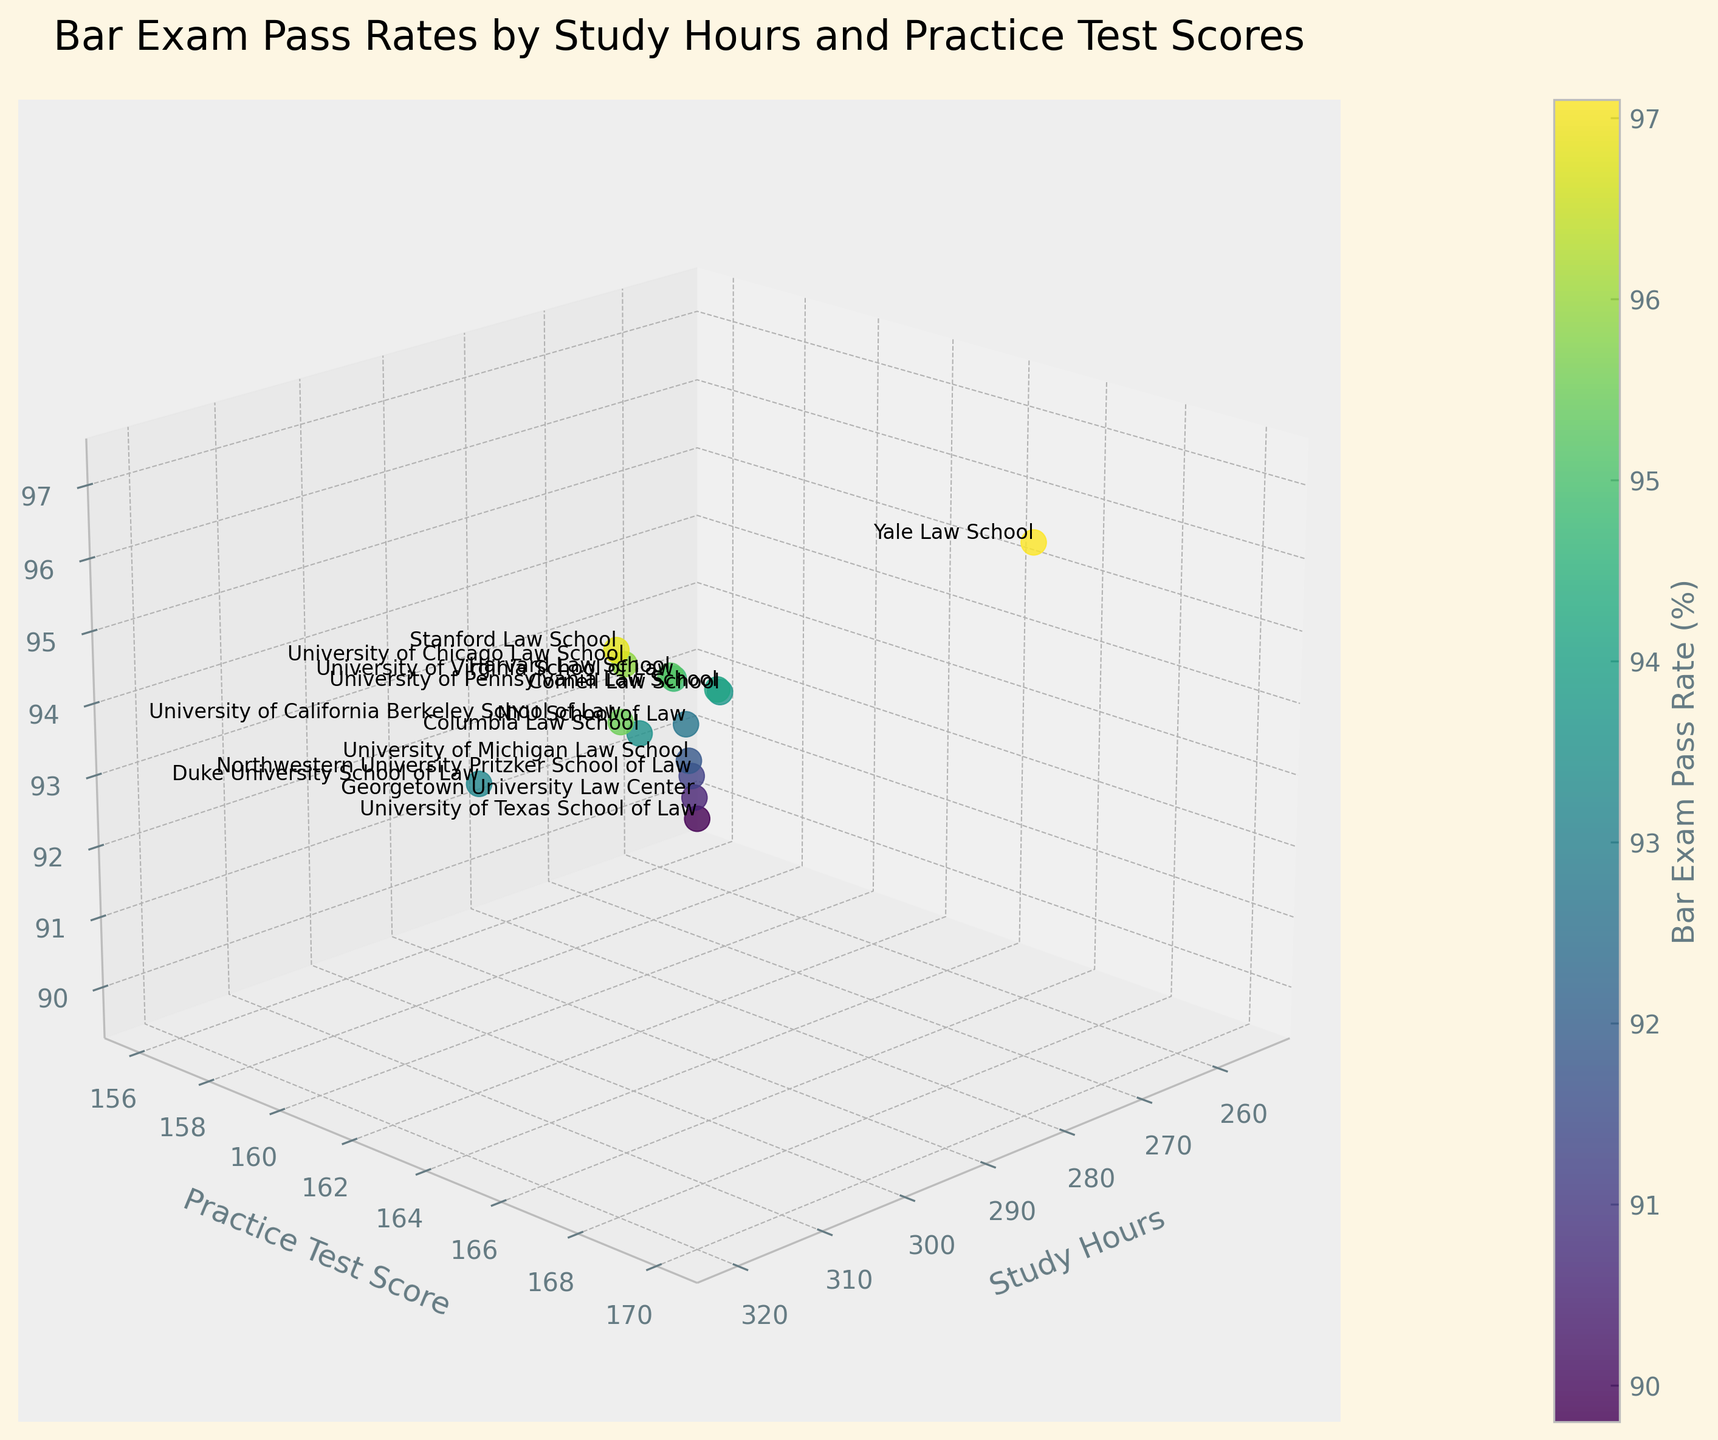What's the title of the 3D plot? The title of the plot is written at the top of the figure. The image shows "Bar Exam Pass Rates by Study Hours and Practice Test Scores" as the title.
Answer: Bar Exam Pass Rates by Study Hours and Practice Test Scores How many law schools are represented in the plot? Each data point represents a law school, and the plot includes the names of each law school. Counting the number of different names, there are 15 law schools shown.
Answer: 15 Which law school has the highest bar exam pass rate? By looking at the z-axis labeled "Bar Exam Pass Rate (%)" and identifying the highest point, Yale Law School, located at the topmost position in the z-axis with a 97.1% pass rate, has the highest bar exam pass rate.
Answer: Yale Law School What is the relationship between study hours and bar exam pass rate? By examining the plot's trend along the x-axis (Study Hours) and z-axis (Bar Exam Pass Rate), it can be observed that generally, as study hours increase, the bar exam pass rate tends to increase.
Answer: Positive correlation Which two law schools have the same bar exam pass rate? By looking at the z-axis values and matching them, Cornell Law School and Columbia Law School both have a pass rate of 93.5%.
Answer: Cornell Law School and Columbia Law School What range of practice test scores is associated with a bar exam pass rate above 94%? By observing the 3D plot, focusing on data points above the 94% bar exam pass rate on the z-axis, corresponding practice test scores range from 163 to 170 on the y-axis.
Answer: 163 to 170 Which law school has the lowest bar exam pass rate, and what are its study hours and practice test score? By identifying the lowest point on the z-axis for bar exam pass rate, the University of Texas School of Law has the lowest pass rate at 89.8%, with 255 study hours and a practice test score of 156.
Answer: University of Texas School of Law; 255 study hours; Practice Test Score 156 How does Stanford Law School's bar exam pass rate compare to Harvard Law School's? On the z-axis, Stanford Law School's pass rate is 96.8%, while Harvard Law School's pass rate is 95.2%. Since 96.8% is greater than 95.2%, Stanford has a higher pass rate.
Answer: Stanford is higher If a law school has 300 study hours and 165 practice test scores, what is its bar exam pass rate? Searching the plot for the data point located at 300 study hours on the x-axis and 165 practice test scores on the y-axis, the corresponding z-axis value shows a bar exam pass rate of 95.2%, which corresponds to Harvard Law School.
Answer: 95.2% What is the average bar exam pass rate for the top five law schools based on practice test scores? Identifying the top five law schools by practice test scores: Yale (170), Stanford (168), Berkeley (167), Chicago (166), and Harvard (165). Averaging their pass rates: (97.1 + 96.8 + 95.5 + 95.9 + 95.2) / 5 = 96.1%.
Answer: 96.1% 